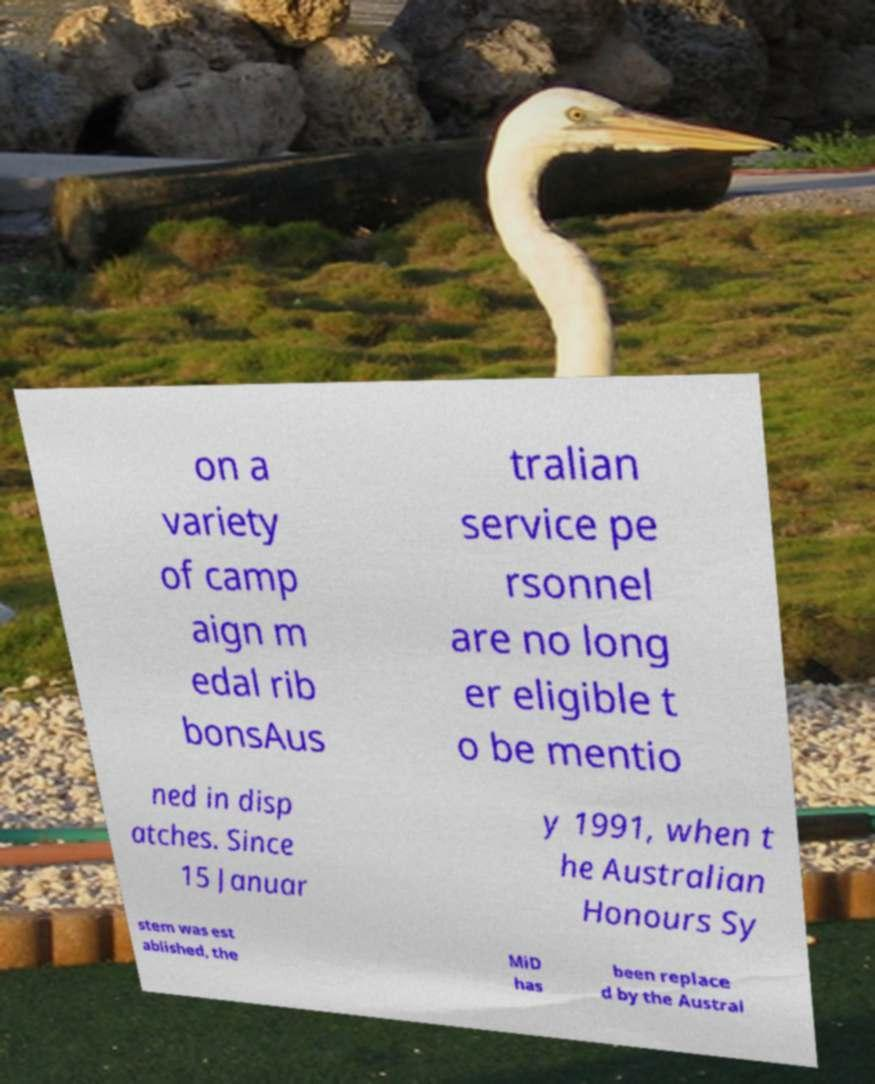Please read and relay the text visible in this image. What does it say? on a variety of camp aign m edal rib bonsAus tralian service pe rsonnel are no long er eligible t o be mentio ned in disp atches. Since 15 Januar y 1991, when t he Australian Honours Sy stem was est ablished, the MiD has been replace d by the Austral 